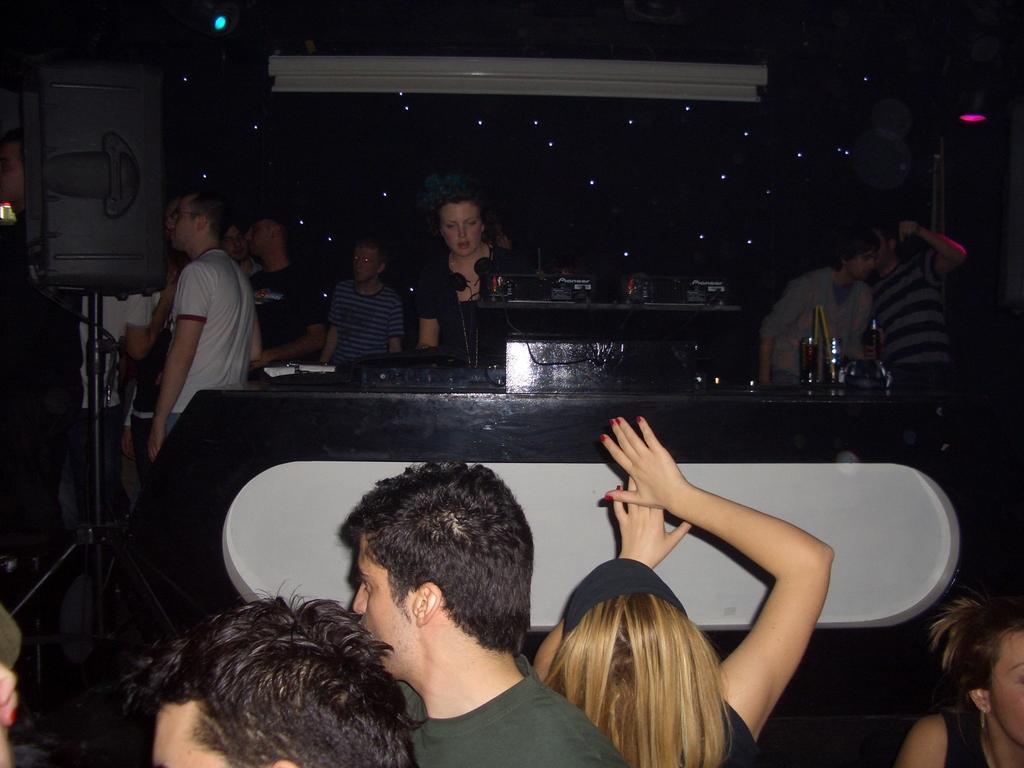In one or two sentences, can you explain what this image depicts? In front of the image there are a few people, in front of them on the table there are some objects, behind the table there are a few other people standing, beside them there are speakers, behind them there is a screen. 